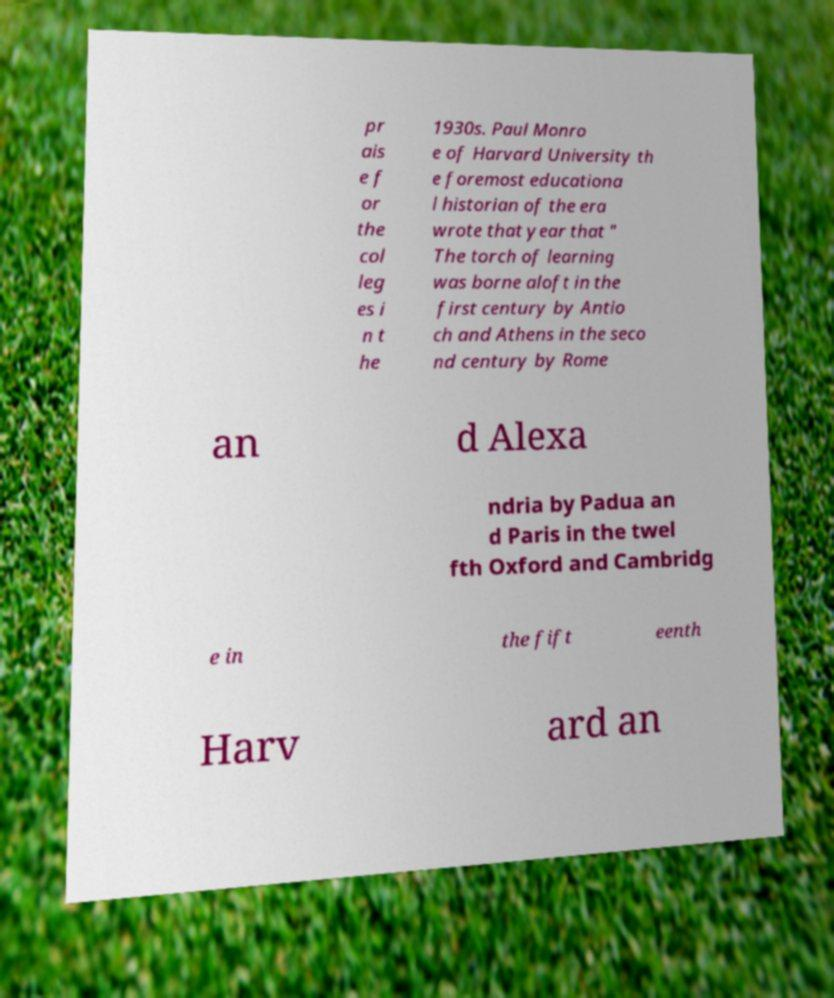There's text embedded in this image that I need extracted. Can you transcribe it verbatim? pr ais e f or the col leg es i n t he 1930s. Paul Monro e of Harvard University th e foremost educationa l historian of the era wrote that year that " The torch of learning was borne aloft in the first century by Antio ch and Athens in the seco nd century by Rome an d Alexa ndria by Padua an d Paris in the twel fth Oxford and Cambridg e in the fift eenth Harv ard an 